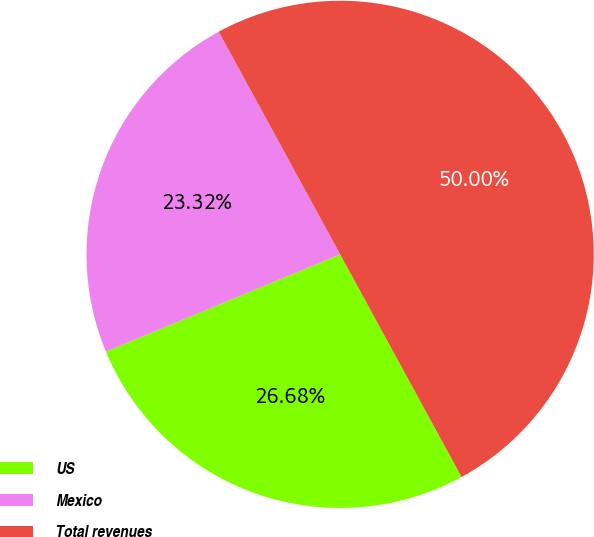Convert chart. <chart><loc_0><loc_0><loc_500><loc_500><pie_chart><fcel>US<fcel>Mexico<fcel>Total revenues<nl><fcel>26.68%<fcel>23.32%<fcel>50.0%<nl></chart> 